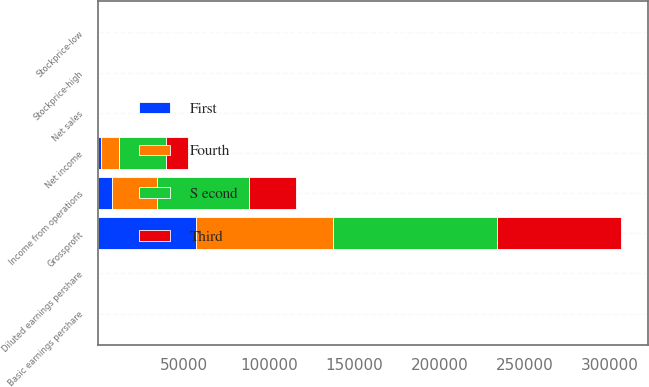Convert chart. <chart><loc_0><loc_0><loc_500><loc_500><stacked_bar_chart><ecel><fcel>Net sales<fcel>Grossprofit<fcel>Income from operations<fcel>Net income<fcel>Basic earnings pershare<fcel>Diluted earnings pershare<fcel>Stockprice-high<fcel>Stockprice-low<nl><fcel>Third<fcel>24.54<fcel>73266<fcel>27532<fcel>12619<fcel>0.12<fcel>0.12<fcel>25.63<fcel>21.87<nl><fcel>S econd<fcel>24.54<fcel>95915<fcel>54280<fcel>27760<fcel>0.26<fcel>0.26<fcel>24.91<fcel>20.09<nl><fcel>Fourth<fcel>24.54<fcel>80501<fcel>26302<fcel>10566<fcel>0.1<fcel>0.1<fcel>22.43<fcel>19.13<nl><fcel>First<fcel>24.54<fcel>57129<fcel>8012<fcel>1659<fcel>0.02<fcel>0.02<fcel>24.17<fcel>18.24<nl></chart> 